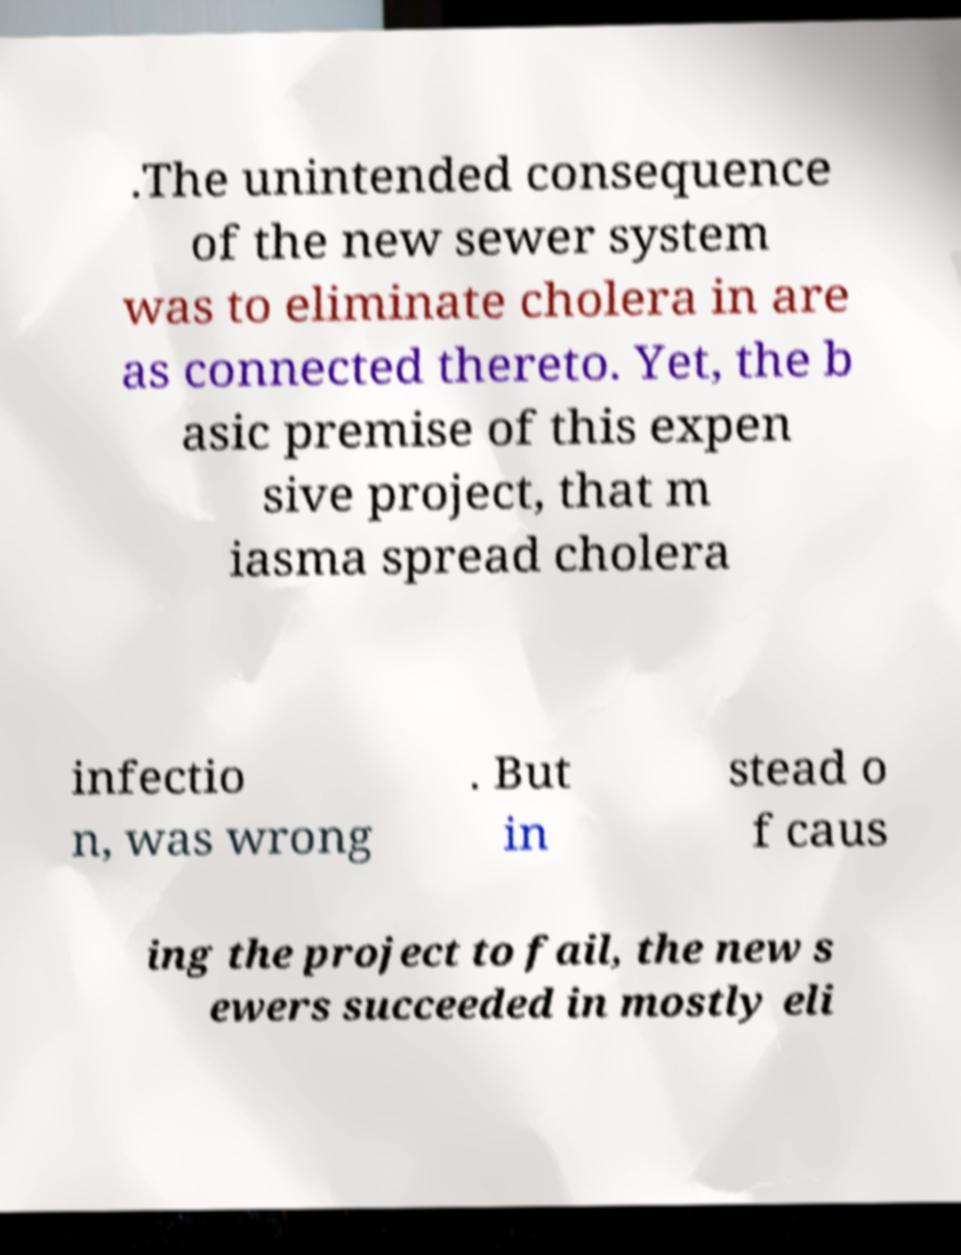What messages or text are displayed in this image? I need them in a readable, typed format. .The unintended consequence of the new sewer system was to eliminate cholera in are as connected thereto. Yet, the b asic premise of this expen sive project, that m iasma spread cholera infectio n, was wrong . But in stead o f caus ing the project to fail, the new s ewers succeeded in mostly eli 